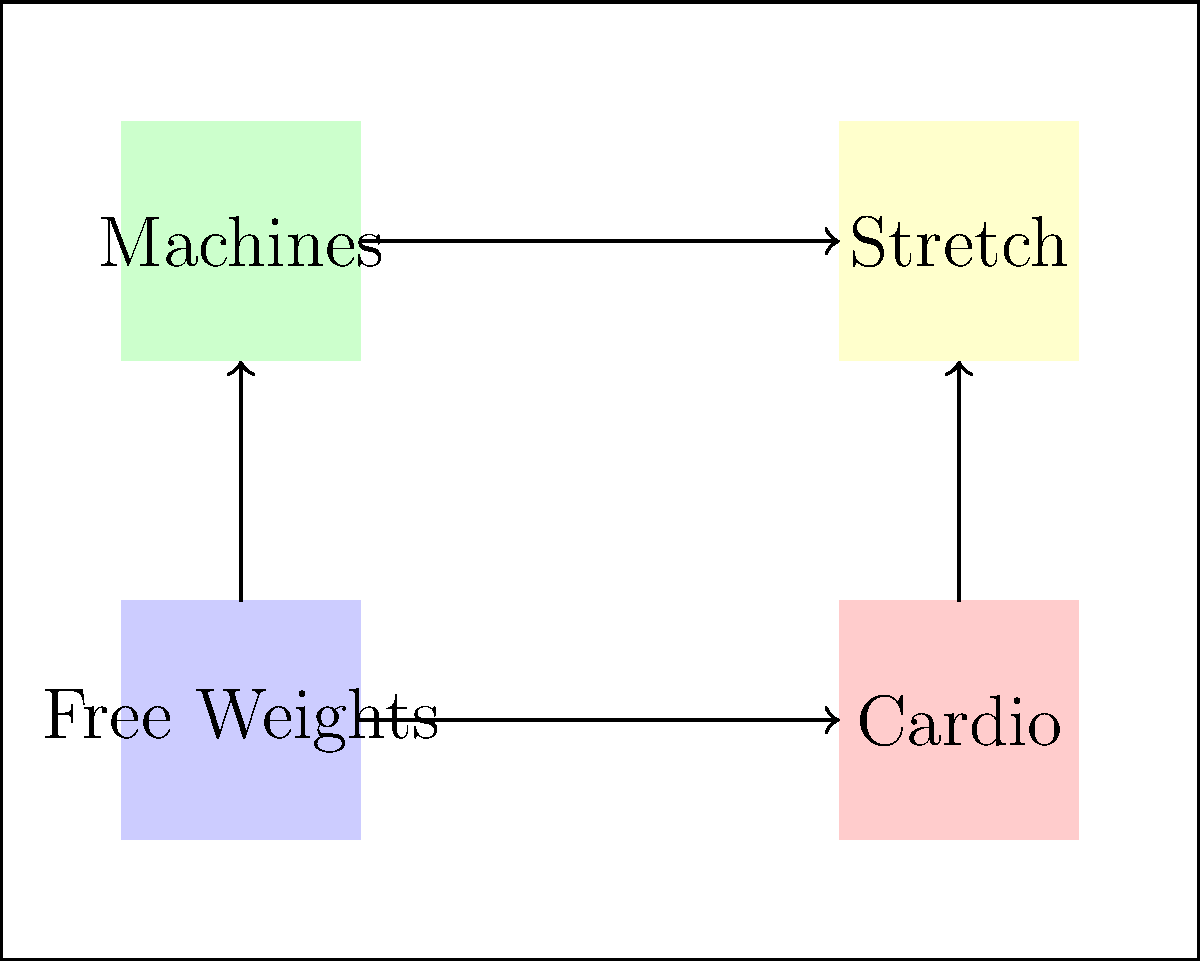As a strength and conditioning coach, you're tasked with optimizing the layout of a new gym space for your teenage athletes. Given the diagram showing different equipment areas and traffic flow, which arrangement principle is most crucial for maximizing efficiency and safety? To answer this question, let's analyze the gym layout and consider the key principles of gym design:

1. Zone Separation: The layout clearly separates different types of equipment into distinct zones (free weights, cardio, machines, and stretching).

2. Traffic Flow: Arrows indicate the main paths athletes would take between zones, showing a circular flow that minimizes congestion.

3. Safety Considerations: 
   - Free weights and machine areas are on opposite sides, reducing the risk of accidents from dropped weights near machine users.
   - The stretching area is placed away from high-activity zones, providing a safer space for warm-ups and cool-downs.

4. Efficiency:
   - Related activities are grouped together (e.g., free weights and machines for strength training).
   - The layout allows for easy transitions between different types of exercises.

5. Space Utilization: The arrangement makes use of the entire gym space, with activities spread out to avoid overcrowding in any one area.

While all these principles are important, the most crucial for maximizing both efficiency and safety is the traffic flow. A well-designed traffic flow:
- Reduces the risk of collisions between athletes moving between stations
- Minimizes congestion, allowing for smoother transitions and more efficient workouts
- Naturally guides athletes through a logical progression of exercises
- Helps maintain separation between different activity zones, enhancing safety

The circular flow shown in the diagram achieves these goals by creating a clear, intuitive path through the gym that connects all areas while minimizing cross-traffic.
Answer: Optimized traffic flow 